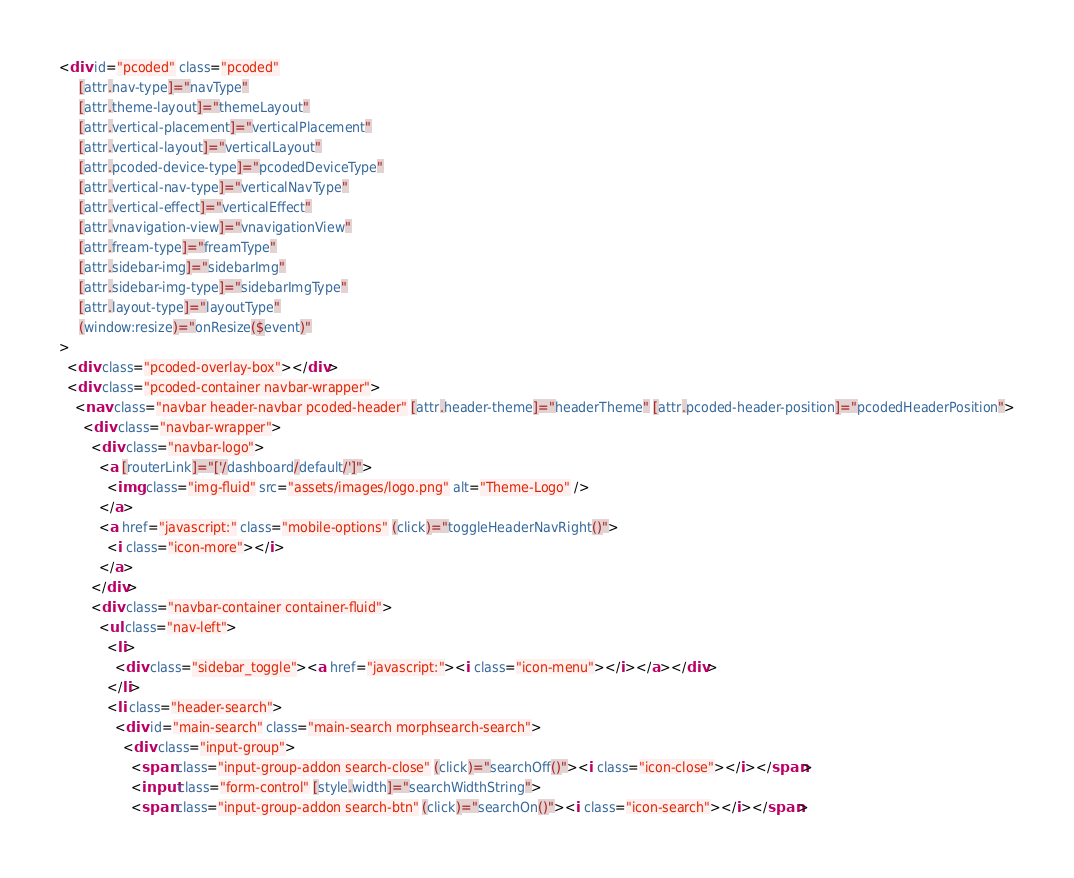<code> <loc_0><loc_0><loc_500><loc_500><_HTML_><div id="pcoded" class="pcoded"
     [attr.nav-type]="navType"
     [attr.theme-layout]="themeLayout"
     [attr.vertical-placement]="verticalPlacement"
     [attr.vertical-layout]="verticalLayout"
     [attr.pcoded-device-type]="pcodedDeviceType"
     [attr.vertical-nav-type]="verticalNavType"
     [attr.vertical-effect]="verticalEffect"
     [attr.vnavigation-view]="vnavigationView"
     [attr.fream-type]="freamType"
     [attr.sidebar-img]="sidebarImg"
     [attr.sidebar-img-type]="sidebarImgType"
     [attr.layout-type]="layoutType"
     (window:resize)="onResize($event)"
>
  <div class="pcoded-overlay-box"></div>
  <div class="pcoded-container navbar-wrapper">
    <nav class="navbar header-navbar pcoded-header" [attr.header-theme]="headerTheme" [attr.pcoded-header-position]="pcodedHeaderPosition">
      <div class="navbar-wrapper">
        <div class="navbar-logo">
          <a [routerLink]="['/dashboard/default/']">
            <img class="img-fluid" src="assets/images/logo.png" alt="Theme-Logo" />
          </a>
          <a href="javascript:" class="mobile-options" (click)="toggleHeaderNavRight()">
            <i class="icon-more"></i>
          </a>
        </div>
        <div class="navbar-container container-fluid">
          <ul class="nav-left">
            <li>
              <div class="sidebar_toggle"><a href="javascript:"><i class="icon-menu"></i></a></div>
            </li>
            <li class="header-search">
              <div id="main-search" class="main-search morphsearch-search">
                <div class="input-group">
                  <span class="input-group-addon search-close" (click)="searchOff()"><i class="icon-close"></i></span>
                  <input class="form-control" [style.width]="searchWidthString">
                  <span class="input-group-addon search-btn" (click)="searchOn()"><i class="icon-search"></i></span></code> 